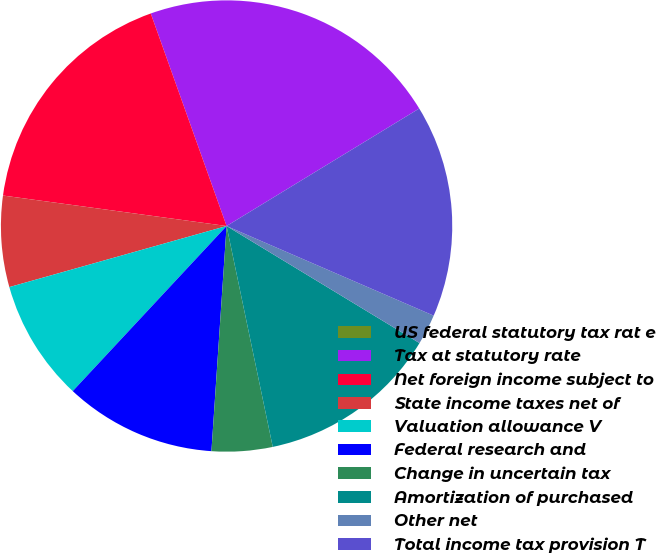Convert chart to OTSL. <chart><loc_0><loc_0><loc_500><loc_500><pie_chart><fcel>US federal statutory tax rat e<fcel>Tax at statutory rate<fcel>Net foreign income subject to<fcel>State income taxes net of<fcel>Valuation allowance V<fcel>Federal research and<fcel>Change in uncertain tax<fcel>Amortization of purchased<fcel>Other net<fcel>Total income tax provision T<nl><fcel>0.0%<fcel>21.74%<fcel>17.39%<fcel>6.52%<fcel>8.7%<fcel>10.87%<fcel>4.35%<fcel>13.04%<fcel>2.18%<fcel>15.22%<nl></chart> 